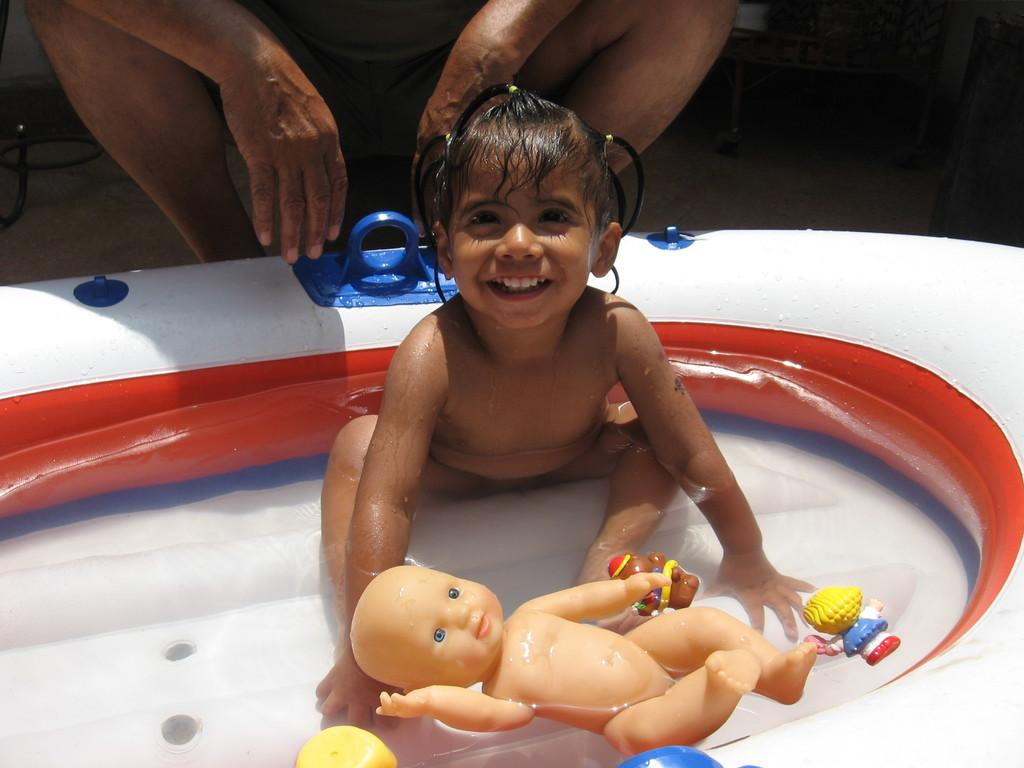Who is present in the image? There is a man, a girl, and a baby in the image. What is the man doing in the image? The man is sitting behind a baby. Where is the girl sitting in the image? The girl is sitting in a tub. What can be seen floating in the water in the image? Toys are floating in the water. What is the primary element visible in the image? There is water visible in the image. What type of cast can be seen on the girl's leg in the image? There is no cast visible on the girl's leg in the image. How many chairs are present in the image? There are no chairs present in the image. 